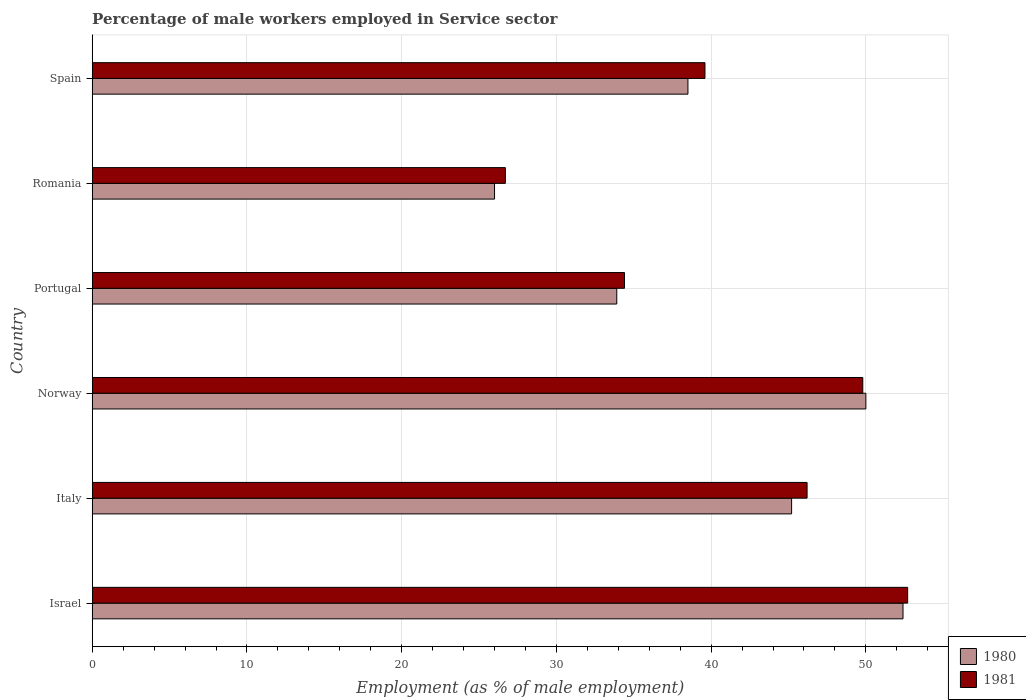How many different coloured bars are there?
Give a very brief answer. 2. How many bars are there on the 1st tick from the top?
Provide a short and direct response. 2. What is the label of the 4th group of bars from the top?
Your response must be concise. Norway. What is the percentage of male workers employed in Service sector in 1981 in Norway?
Give a very brief answer. 49.8. Across all countries, what is the maximum percentage of male workers employed in Service sector in 1981?
Your answer should be very brief. 52.7. Across all countries, what is the minimum percentage of male workers employed in Service sector in 1981?
Give a very brief answer. 26.7. In which country was the percentage of male workers employed in Service sector in 1980 minimum?
Offer a terse response. Romania. What is the total percentage of male workers employed in Service sector in 1981 in the graph?
Give a very brief answer. 249.4. What is the difference between the percentage of male workers employed in Service sector in 1981 in Norway and that in Spain?
Keep it short and to the point. 10.2. What is the difference between the percentage of male workers employed in Service sector in 1981 in Italy and the percentage of male workers employed in Service sector in 1980 in Israel?
Offer a very short reply. -6.2. What is the average percentage of male workers employed in Service sector in 1981 per country?
Your response must be concise. 41.57. What is the difference between the percentage of male workers employed in Service sector in 1981 and percentage of male workers employed in Service sector in 1980 in Italy?
Provide a short and direct response. 1. In how many countries, is the percentage of male workers employed in Service sector in 1980 greater than 40 %?
Ensure brevity in your answer.  3. What is the ratio of the percentage of male workers employed in Service sector in 1981 in Israel to that in Romania?
Give a very brief answer. 1.97. Is the difference between the percentage of male workers employed in Service sector in 1981 in Italy and Spain greater than the difference between the percentage of male workers employed in Service sector in 1980 in Italy and Spain?
Your answer should be very brief. No. What is the difference between the highest and the second highest percentage of male workers employed in Service sector in 1980?
Keep it short and to the point. 2.4. What is the difference between the highest and the lowest percentage of male workers employed in Service sector in 1980?
Your answer should be very brief. 26.4. In how many countries, is the percentage of male workers employed in Service sector in 1981 greater than the average percentage of male workers employed in Service sector in 1981 taken over all countries?
Keep it short and to the point. 3. What does the 1st bar from the top in Portugal represents?
Your answer should be compact. 1981. How many countries are there in the graph?
Offer a terse response. 6. What is the difference between two consecutive major ticks on the X-axis?
Provide a succinct answer. 10. Does the graph contain any zero values?
Ensure brevity in your answer.  No. Does the graph contain grids?
Provide a short and direct response. Yes. How many legend labels are there?
Make the answer very short. 2. How are the legend labels stacked?
Ensure brevity in your answer.  Vertical. What is the title of the graph?
Provide a short and direct response. Percentage of male workers employed in Service sector. What is the label or title of the X-axis?
Make the answer very short. Employment (as % of male employment). What is the Employment (as % of male employment) of 1980 in Israel?
Keep it short and to the point. 52.4. What is the Employment (as % of male employment) in 1981 in Israel?
Offer a very short reply. 52.7. What is the Employment (as % of male employment) in 1980 in Italy?
Your answer should be compact. 45.2. What is the Employment (as % of male employment) of 1981 in Italy?
Ensure brevity in your answer.  46.2. What is the Employment (as % of male employment) in 1981 in Norway?
Keep it short and to the point. 49.8. What is the Employment (as % of male employment) in 1980 in Portugal?
Offer a terse response. 33.9. What is the Employment (as % of male employment) of 1981 in Portugal?
Your response must be concise. 34.4. What is the Employment (as % of male employment) in 1980 in Romania?
Keep it short and to the point. 26. What is the Employment (as % of male employment) in 1981 in Romania?
Your answer should be compact. 26.7. What is the Employment (as % of male employment) in 1980 in Spain?
Make the answer very short. 38.5. What is the Employment (as % of male employment) in 1981 in Spain?
Keep it short and to the point. 39.6. Across all countries, what is the maximum Employment (as % of male employment) of 1980?
Your answer should be compact. 52.4. Across all countries, what is the maximum Employment (as % of male employment) of 1981?
Keep it short and to the point. 52.7. Across all countries, what is the minimum Employment (as % of male employment) in 1980?
Offer a very short reply. 26. Across all countries, what is the minimum Employment (as % of male employment) of 1981?
Provide a short and direct response. 26.7. What is the total Employment (as % of male employment) in 1980 in the graph?
Your answer should be very brief. 246. What is the total Employment (as % of male employment) of 1981 in the graph?
Your answer should be very brief. 249.4. What is the difference between the Employment (as % of male employment) of 1980 in Israel and that in Italy?
Provide a succinct answer. 7.2. What is the difference between the Employment (as % of male employment) of 1981 in Israel and that in Italy?
Ensure brevity in your answer.  6.5. What is the difference between the Employment (as % of male employment) of 1980 in Israel and that in Norway?
Provide a succinct answer. 2.4. What is the difference between the Employment (as % of male employment) of 1980 in Israel and that in Portugal?
Your answer should be compact. 18.5. What is the difference between the Employment (as % of male employment) of 1981 in Israel and that in Portugal?
Give a very brief answer. 18.3. What is the difference between the Employment (as % of male employment) in 1980 in Israel and that in Romania?
Provide a succinct answer. 26.4. What is the difference between the Employment (as % of male employment) of 1981 in Israel and that in Romania?
Ensure brevity in your answer.  26. What is the difference between the Employment (as % of male employment) of 1980 in Israel and that in Spain?
Make the answer very short. 13.9. What is the difference between the Employment (as % of male employment) of 1981 in Italy and that in Norway?
Make the answer very short. -3.6. What is the difference between the Employment (as % of male employment) of 1980 in Italy and that in Portugal?
Provide a short and direct response. 11.3. What is the difference between the Employment (as % of male employment) in 1980 in Italy and that in Spain?
Your answer should be compact. 6.7. What is the difference between the Employment (as % of male employment) in 1980 in Norway and that in Portugal?
Your response must be concise. 16.1. What is the difference between the Employment (as % of male employment) in 1981 in Norway and that in Portugal?
Your answer should be compact. 15.4. What is the difference between the Employment (as % of male employment) of 1980 in Norway and that in Romania?
Ensure brevity in your answer.  24. What is the difference between the Employment (as % of male employment) in 1981 in Norway and that in Romania?
Provide a short and direct response. 23.1. What is the difference between the Employment (as % of male employment) of 1981 in Portugal and that in Romania?
Provide a short and direct response. 7.7. What is the difference between the Employment (as % of male employment) of 1981 in Portugal and that in Spain?
Provide a short and direct response. -5.2. What is the difference between the Employment (as % of male employment) of 1980 in Romania and that in Spain?
Offer a very short reply. -12.5. What is the difference between the Employment (as % of male employment) in 1981 in Romania and that in Spain?
Provide a succinct answer. -12.9. What is the difference between the Employment (as % of male employment) of 1980 in Israel and the Employment (as % of male employment) of 1981 in Romania?
Provide a short and direct response. 25.7. What is the difference between the Employment (as % of male employment) in 1980 in Israel and the Employment (as % of male employment) in 1981 in Spain?
Offer a terse response. 12.8. What is the difference between the Employment (as % of male employment) of 1980 in Italy and the Employment (as % of male employment) of 1981 in Norway?
Provide a short and direct response. -4.6. What is the difference between the Employment (as % of male employment) of 1980 in Italy and the Employment (as % of male employment) of 1981 in Portugal?
Your response must be concise. 10.8. What is the difference between the Employment (as % of male employment) in 1980 in Norway and the Employment (as % of male employment) in 1981 in Romania?
Offer a very short reply. 23.3. What is the difference between the Employment (as % of male employment) of 1980 in Norway and the Employment (as % of male employment) of 1981 in Spain?
Give a very brief answer. 10.4. What is the average Employment (as % of male employment) in 1981 per country?
Give a very brief answer. 41.57. What is the difference between the Employment (as % of male employment) of 1980 and Employment (as % of male employment) of 1981 in Israel?
Make the answer very short. -0.3. What is the difference between the Employment (as % of male employment) in 1980 and Employment (as % of male employment) in 1981 in Norway?
Your answer should be compact. 0.2. What is the ratio of the Employment (as % of male employment) in 1980 in Israel to that in Italy?
Offer a terse response. 1.16. What is the ratio of the Employment (as % of male employment) in 1981 in Israel to that in Italy?
Offer a terse response. 1.14. What is the ratio of the Employment (as % of male employment) in 1980 in Israel to that in Norway?
Give a very brief answer. 1.05. What is the ratio of the Employment (as % of male employment) in 1981 in Israel to that in Norway?
Make the answer very short. 1.06. What is the ratio of the Employment (as % of male employment) of 1980 in Israel to that in Portugal?
Ensure brevity in your answer.  1.55. What is the ratio of the Employment (as % of male employment) in 1981 in Israel to that in Portugal?
Provide a short and direct response. 1.53. What is the ratio of the Employment (as % of male employment) in 1980 in Israel to that in Romania?
Make the answer very short. 2.02. What is the ratio of the Employment (as % of male employment) in 1981 in Israel to that in Romania?
Provide a succinct answer. 1.97. What is the ratio of the Employment (as % of male employment) of 1980 in Israel to that in Spain?
Offer a terse response. 1.36. What is the ratio of the Employment (as % of male employment) in 1981 in Israel to that in Spain?
Ensure brevity in your answer.  1.33. What is the ratio of the Employment (as % of male employment) in 1980 in Italy to that in Norway?
Offer a very short reply. 0.9. What is the ratio of the Employment (as % of male employment) in 1981 in Italy to that in Norway?
Make the answer very short. 0.93. What is the ratio of the Employment (as % of male employment) of 1980 in Italy to that in Portugal?
Offer a very short reply. 1.33. What is the ratio of the Employment (as % of male employment) of 1981 in Italy to that in Portugal?
Your response must be concise. 1.34. What is the ratio of the Employment (as % of male employment) of 1980 in Italy to that in Romania?
Ensure brevity in your answer.  1.74. What is the ratio of the Employment (as % of male employment) in 1981 in Italy to that in Romania?
Your response must be concise. 1.73. What is the ratio of the Employment (as % of male employment) in 1980 in Italy to that in Spain?
Make the answer very short. 1.17. What is the ratio of the Employment (as % of male employment) of 1980 in Norway to that in Portugal?
Your answer should be compact. 1.47. What is the ratio of the Employment (as % of male employment) in 1981 in Norway to that in Portugal?
Your answer should be very brief. 1.45. What is the ratio of the Employment (as % of male employment) of 1980 in Norway to that in Romania?
Provide a short and direct response. 1.92. What is the ratio of the Employment (as % of male employment) of 1981 in Norway to that in Romania?
Keep it short and to the point. 1.87. What is the ratio of the Employment (as % of male employment) in 1980 in Norway to that in Spain?
Keep it short and to the point. 1.3. What is the ratio of the Employment (as % of male employment) of 1981 in Norway to that in Spain?
Your response must be concise. 1.26. What is the ratio of the Employment (as % of male employment) of 1980 in Portugal to that in Romania?
Offer a very short reply. 1.3. What is the ratio of the Employment (as % of male employment) of 1981 in Portugal to that in Romania?
Make the answer very short. 1.29. What is the ratio of the Employment (as % of male employment) of 1980 in Portugal to that in Spain?
Give a very brief answer. 0.88. What is the ratio of the Employment (as % of male employment) of 1981 in Portugal to that in Spain?
Your answer should be compact. 0.87. What is the ratio of the Employment (as % of male employment) in 1980 in Romania to that in Spain?
Provide a short and direct response. 0.68. What is the ratio of the Employment (as % of male employment) of 1981 in Romania to that in Spain?
Your answer should be compact. 0.67. What is the difference between the highest and the lowest Employment (as % of male employment) of 1980?
Your response must be concise. 26.4. 